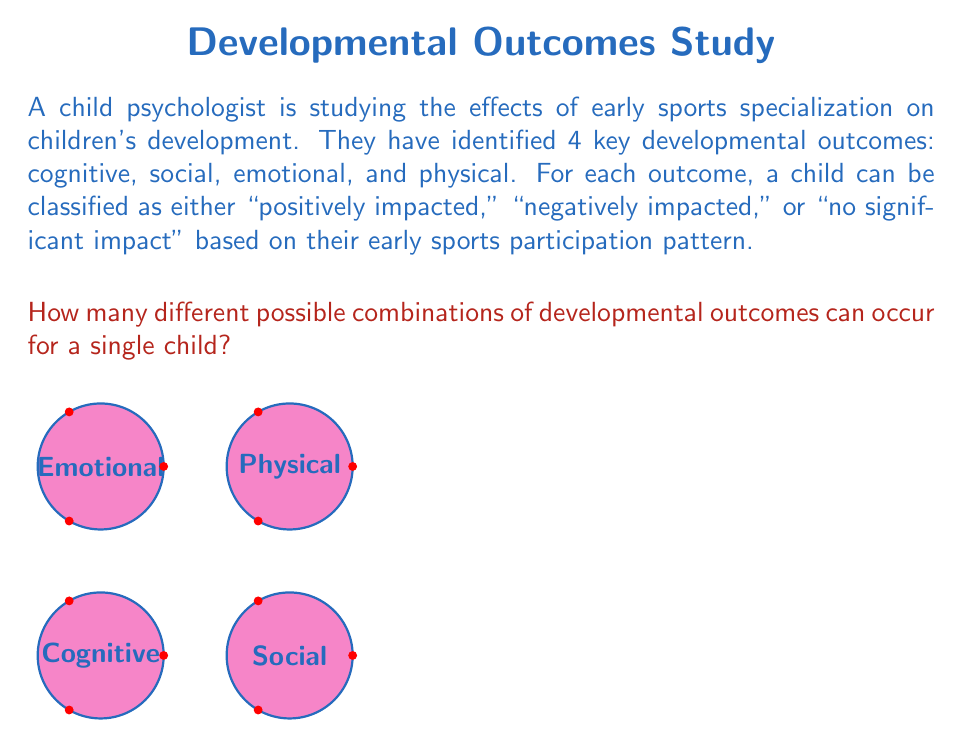Teach me how to tackle this problem. To solve this problem, we need to use the multiplication principle of counting. Let's break it down step by step:

1) We have 4 developmental outcomes: cognitive, social, emotional, and physical.

2) For each outcome, there are 3 possible classifications:
   - Positively impacted
   - Negatively impacted
   - No significant impact

3) We need to choose one classification for each outcome. This is a case of independent events, where the choice for one outcome doesn't affect the choices for the others.

4) According to the multiplication principle, when we have independent events, we multiply the number of possibilities for each event to get the total number of possible outcomes.

5) In this case, we have:
   $$ 3 \text{ choices for cognitive} \times 3 \text{ choices for social} \times 3 \text{ choices for emotional} \times 3 \text{ choices for physical} $$

6) This can be written as:
   $$ 3 \times 3 \times 3 \times 3 = 3^4 $$

7) Calculating this:
   $$ 3^4 = 81 $$

Therefore, there are 81 different possible combinations of developmental outcomes for a single child based on their early sports participation pattern.
Answer: $3^4 = 81$ combinations 